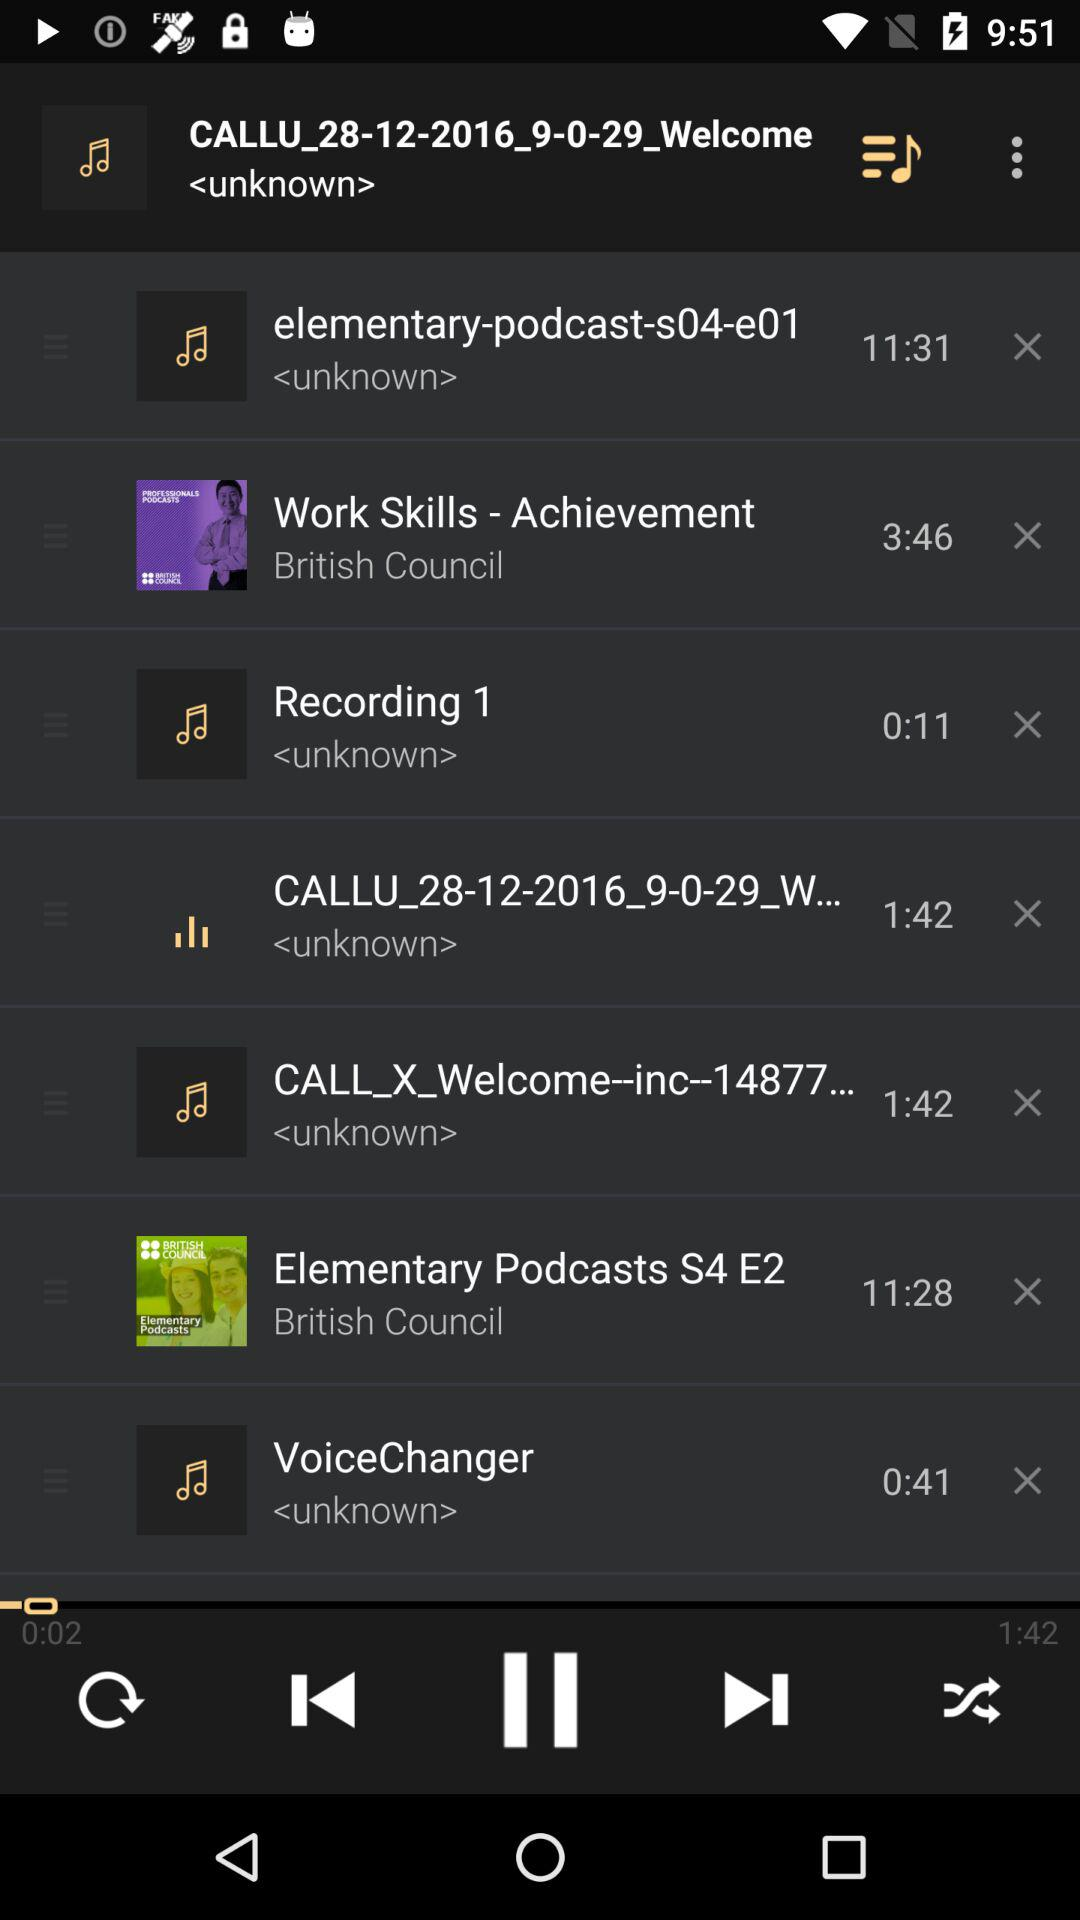What is the duration of "Recording 1"? The duration is 0:11. 